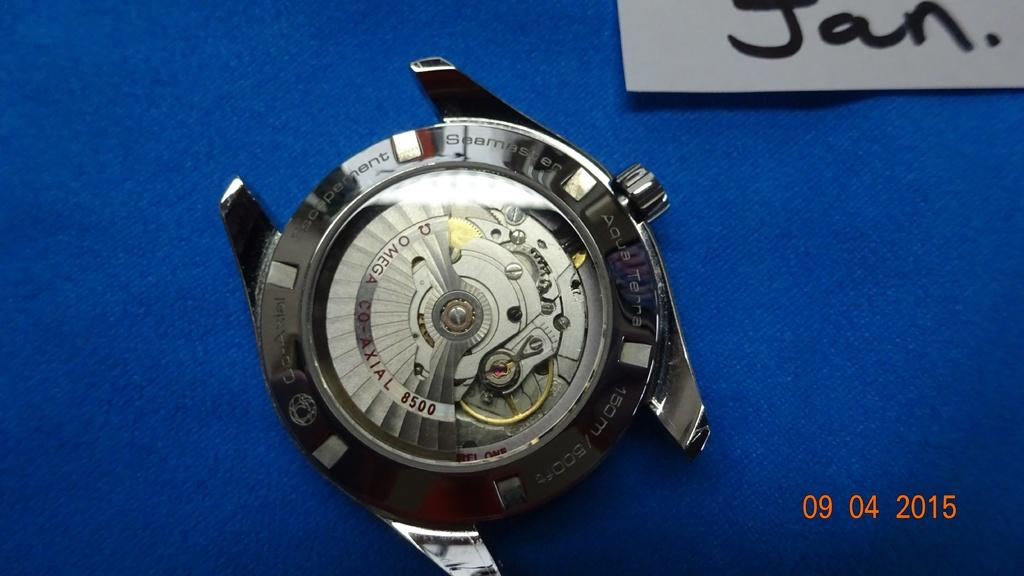<image>
Present a compact description of the photo's key features. A watch is shown, with the month Jan. displayed in the top right 